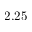<formula> <loc_0><loc_0><loc_500><loc_500>2 . 2 5</formula> 